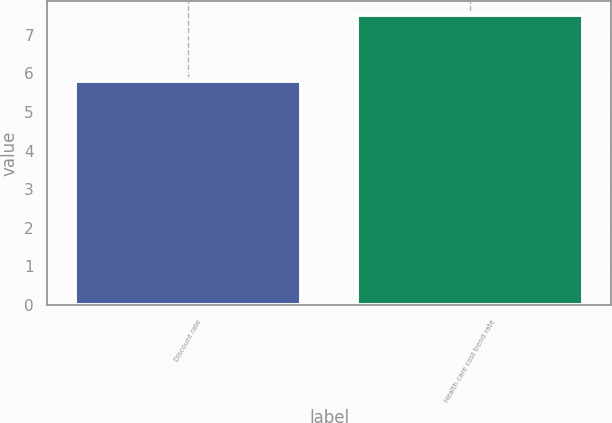<chart> <loc_0><loc_0><loc_500><loc_500><bar_chart><fcel>Discount rate<fcel>Health care cost trend rate<nl><fcel>5.8<fcel>7.5<nl></chart> 